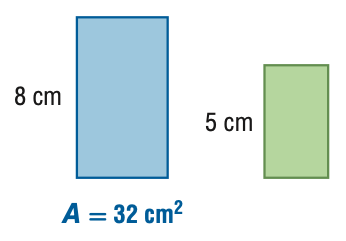Answer the mathemtical geometry problem and directly provide the correct option letter.
Question: For the pair of similar figures, find the area of the green figure.
Choices: A: 12.5 B: 20.0 C: 51.2 D: 81.9 A 